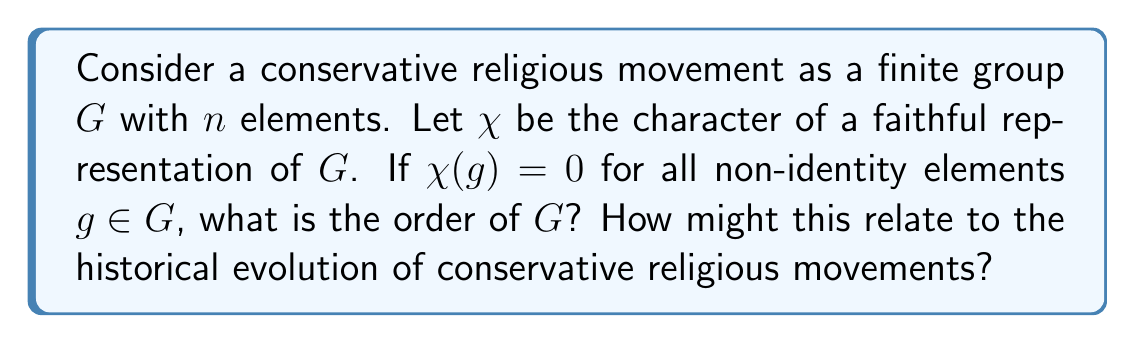Solve this math problem. Let's approach this step-by-step:

1) First, recall that for any character $\chi$ of a finite group $G$:

   $$\sum_{g \in G} |\chi(g)|^2 = |G| \cdot (\text{dim } \chi)$$

2) In our case, $\chi(g) = 0$ for all non-identity elements. Let $e$ be the identity element. Then:

   $$|\chi(e)|^2 + \sum_{g \neq e} |\chi(g)|^2 = |G| \cdot (\text{dim } \chi)$$

3) This simplifies to:

   $$|\chi(e)|^2 = |G| \cdot (\text{dim } \chi)$$

4) Now, for a faithful representation, $\text{dim } \chi \geq \sqrt{|G|}$. This is because a faithful representation must have at least as many dimensions as the square root of the group order.

5) Also, $\chi(e) = \text{dim } \chi$ for any representation.

6) Substituting these into our equation:

   $$(\text{dim } \chi)^2 = |G| \cdot (\text{dim } \chi)$$

7) Dividing both sides by $\text{dim } \chi$:

   $$\text{dim } \chi = |G|$$

8) But we know $\text{dim } \chi \geq \sqrt{|G|}$, so:

   $$|G| \geq \sqrt{|G|}$$

9) The only positive integer that satisfies this is 1.

This result suggests that the only group satisfying these conditions is the trivial group of order 1. In the context of conservative religious movements, this could be interpreted as representing a movement that has become so rigid and exclusive that it has reduced to a single individual or perspective, losing all internal diversity.
Answer: $|G| = 1$ 